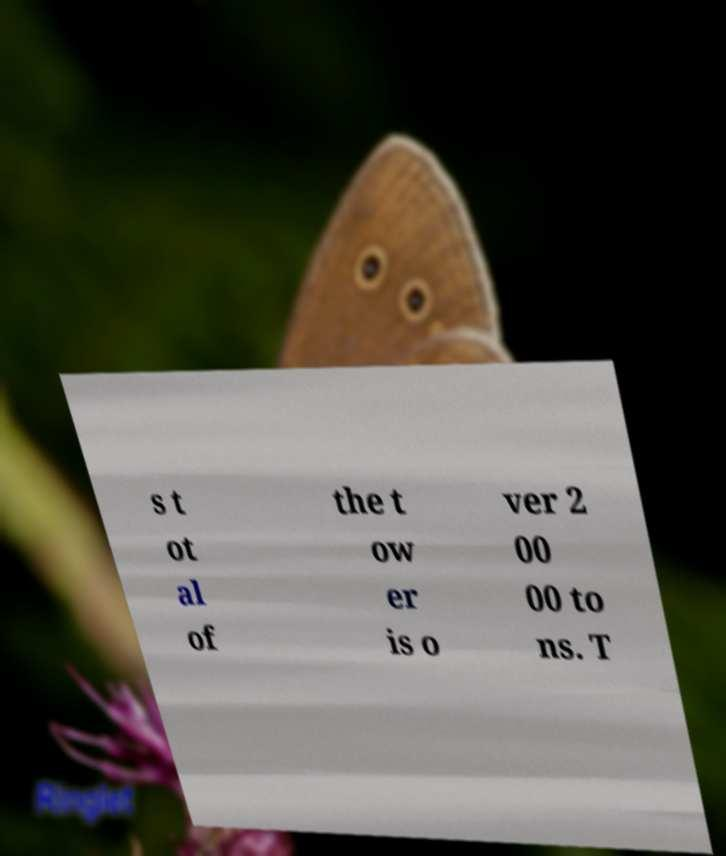Can you accurately transcribe the text from the provided image for me? s t ot al of the t ow er is o ver 2 00 00 to ns. T 